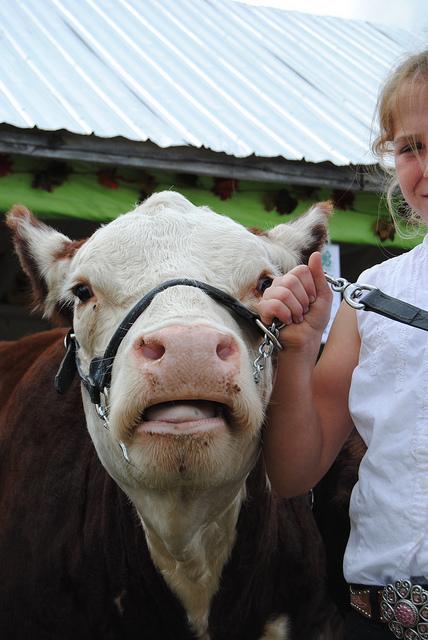What color is the cow?
Answer briefly. Brown and white. Is the cow looking forward or backward?
Quick response, please. Forward. What is the girl holding in her right hand?
Answer briefly. Harness. 